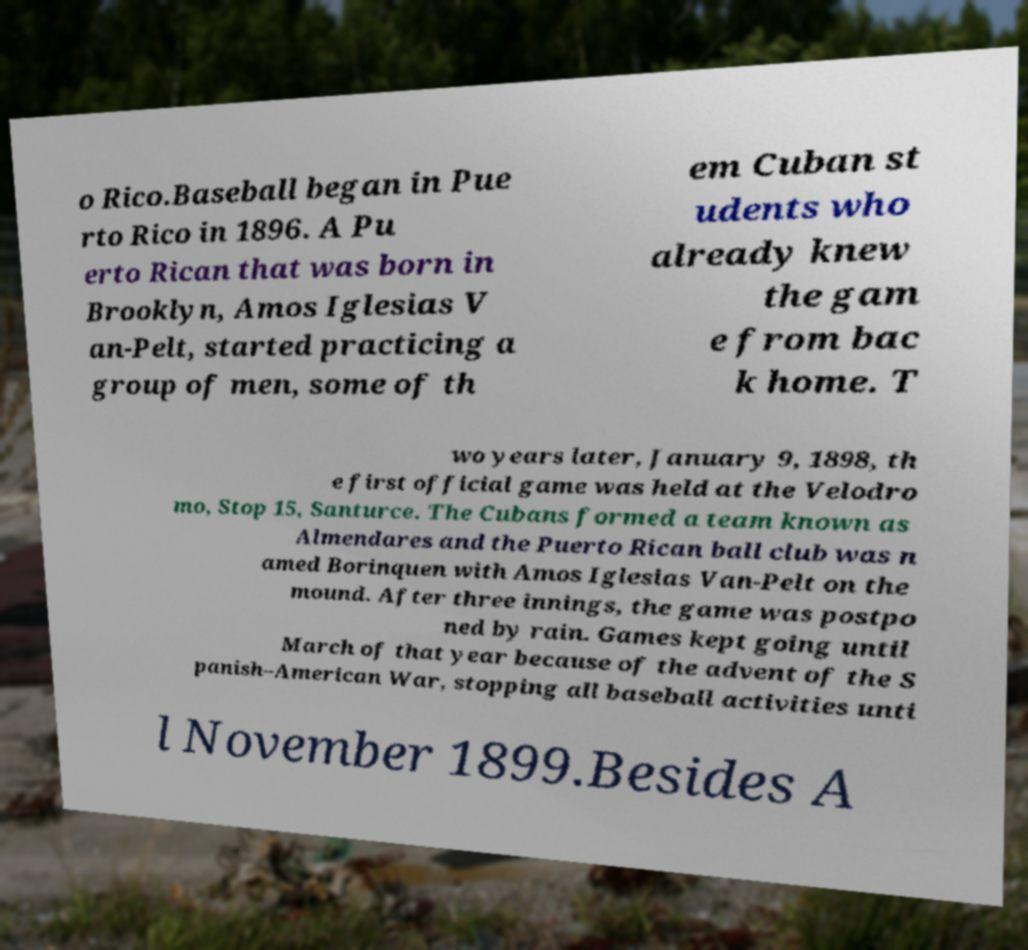Could you assist in decoding the text presented in this image and type it out clearly? o Rico.Baseball began in Pue rto Rico in 1896. A Pu erto Rican that was born in Brooklyn, Amos Iglesias V an-Pelt, started practicing a group of men, some of th em Cuban st udents who already knew the gam e from bac k home. T wo years later, January 9, 1898, th e first official game was held at the Velodro mo, Stop 15, Santurce. The Cubans formed a team known as Almendares and the Puerto Rican ball club was n amed Borinquen with Amos Iglesias Van-Pelt on the mound. After three innings, the game was postpo ned by rain. Games kept going until March of that year because of the advent of the S panish–American War, stopping all baseball activities unti l November 1899.Besides A 